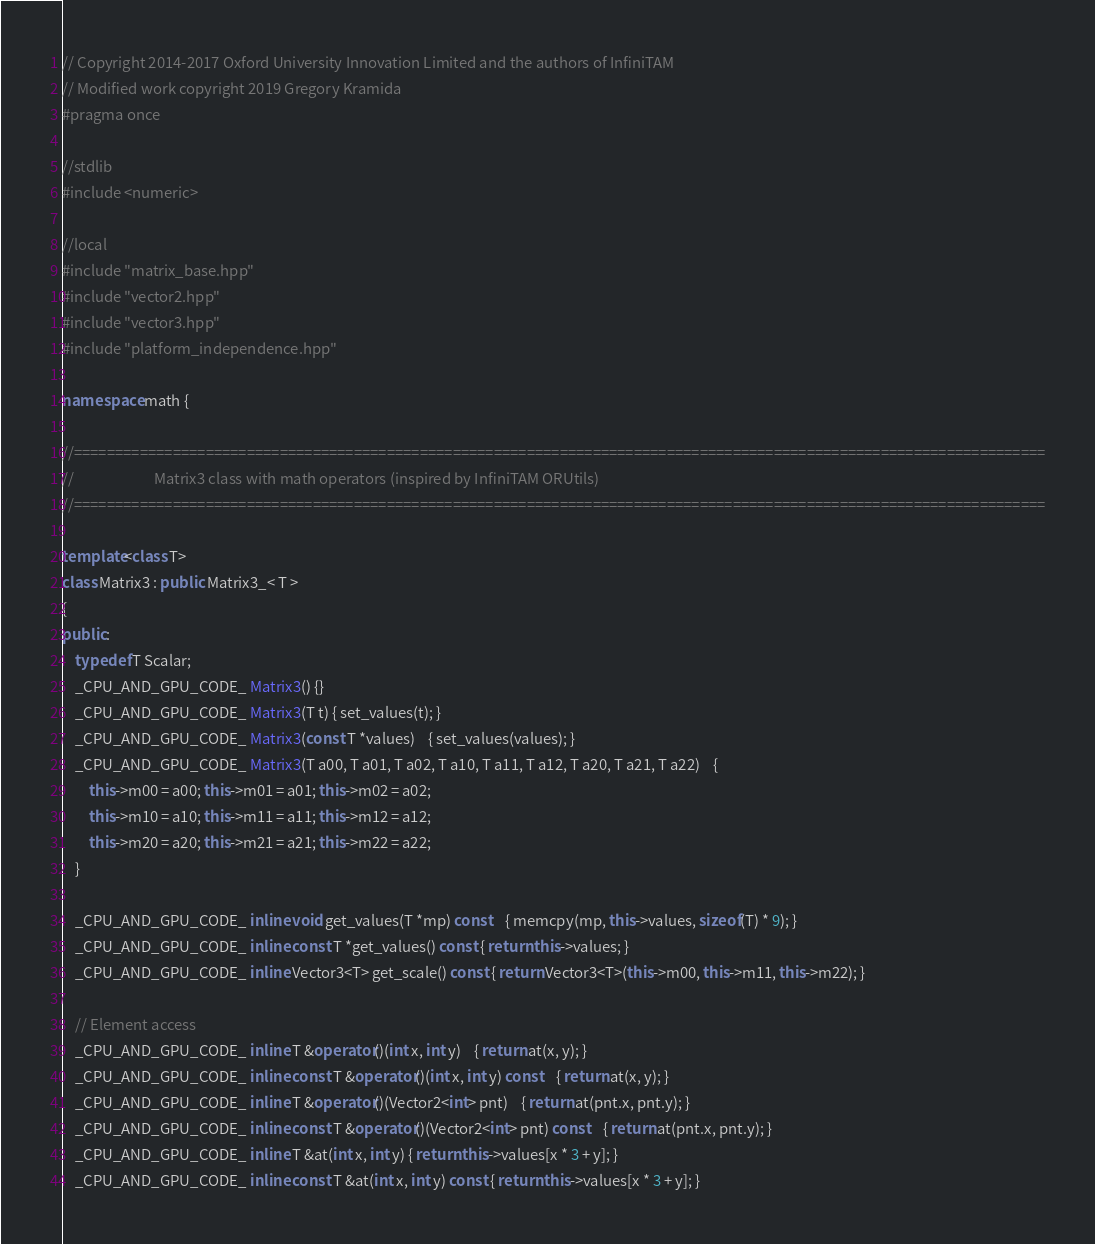Convert code to text. <code><loc_0><loc_0><loc_500><loc_500><_C++_>// Copyright 2014-2017 Oxford University Innovation Limited and the authors of InfiniTAM
// Modified work copyright 2019 Gregory Kramida
#pragma once

//stdlib
#include <numeric>

//local
#include "matrix_base.hpp"
#include "vector2.hpp"
#include "vector3.hpp"
#include "platform_independence.hpp"

namespace math {

//======================================================================================================================
//                        Matrix3 class with math operators (inspired by InfiniTAM ORUtils)
//======================================================================================================================

template<class T>
class Matrix3 : public Matrix3_< T >
{
public:
	typedef T Scalar;
	_CPU_AND_GPU_CODE_ Matrix3() {}
	_CPU_AND_GPU_CODE_ Matrix3(T t) { set_values(t); }
	_CPU_AND_GPU_CODE_ Matrix3(const T *values)	{ set_values(values); }
	_CPU_AND_GPU_CODE_ Matrix3(T a00, T a01, T a02, T a10, T a11, T a12, T a20, T a21, T a22)	{
		this->m00 = a00; this->m01 = a01; this->m02 = a02;
		this->m10 = a10; this->m11 = a11; this->m12 = a12;
		this->m20 = a20; this->m21 = a21; this->m22 = a22;
	}

	_CPU_AND_GPU_CODE_ inline void get_values(T *mp) const	{ memcpy(mp, this->values, sizeof(T) * 9); }
	_CPU_AND_GPU_CODE_ inline const T *get_values() const { return this->values; }
	_CPU_AND_GPU_CODE_ inline Vector3<T> get_scale() const { return Vector3<T>(this->m00, this->m11, this->m22); }

	// Element access
	_CPU_AND_GPU_CODE_ inline T &operator()(int x, int y)	{ return at(x, y); }
	_CPU_AND_GPU_CODE_ inline const T &operator()(int x, int y) const	{ return at(x, y); }
	_CPU_AND_GPU_CODE_ inline T &operator()(Vector2<int> pnt)	{ return at(pnt.x, pnt.y); }
	_CPU_AND_GPU_CODE_ inline const T &operator()(Vector2<int> pnt) const	{ return at(pnt.x, pnt.y); }
	_CPU_AND_GPU_CODE_ inline T &at(int x, int y) { return this->values[x * 3 + y]; }
	_CPU_AND_GPU_CODE_ inline const T &at(int x, int y) const { return this->values[x * 3 + y]; }
</code> 